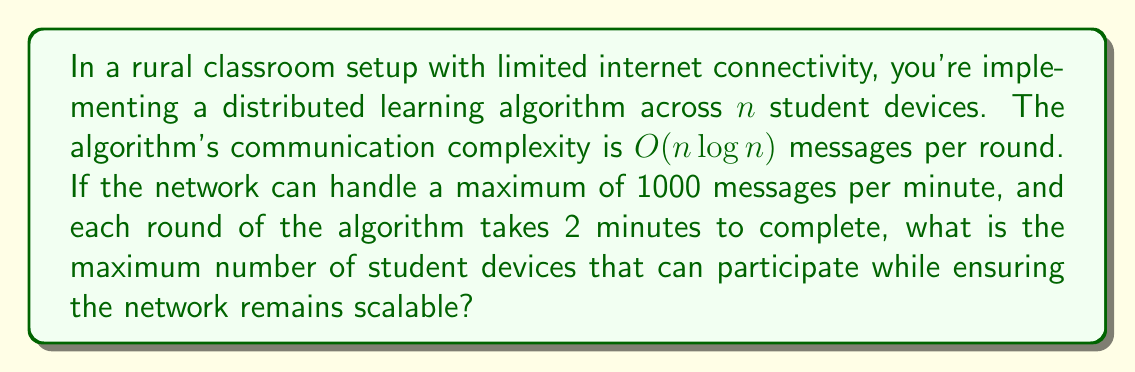Can you solve this math problem? To solve this problem, we need to follow these steps:

1) First, let's establish the constraints:
   - The network can handle 1000 messages per minute
   - Each round takes 2 minutes
   - The algorithm's complexity is $O(n \log n)$ messages per round

2) Calculate the maximum number of messages per round:
   $$\text{Messages per round} = 1000 \text{ messages/minute} \times 2 \text{ minutes} = 2000 \text{ messages}$$

3) Set up an equation based on the algorithm's complexity:
   $$n \log n = 2000$$
   
   Here, we're using the exact form rather than big O notation, as we're looking for the maximum value of $n$ that satisfies this equation.

4) This equation can't be solved algebraically, so we need to use numerical methods or estimation.

5) We can start by trying some values:
   - For $n = 100$: $100 \log 100 \approx 460$ (too small)
   - For $n = 200$: $200 \log 200 \approx 1060$ (still too small)
   - For $n = 300$: $300 \log 300 \approx 1721$ (getting closer)
   - For $n = 350$: $350 \log 350 \approx 2056$ (slightly too large)

6) Through further refinement, we can find that the closest integer solution is:
   $$346 \log 346 \approx 1999.7$$

Therefore, the maximum number of student devices that can participate while keeping the network scalable is 346.
Answer: 346 student devices 